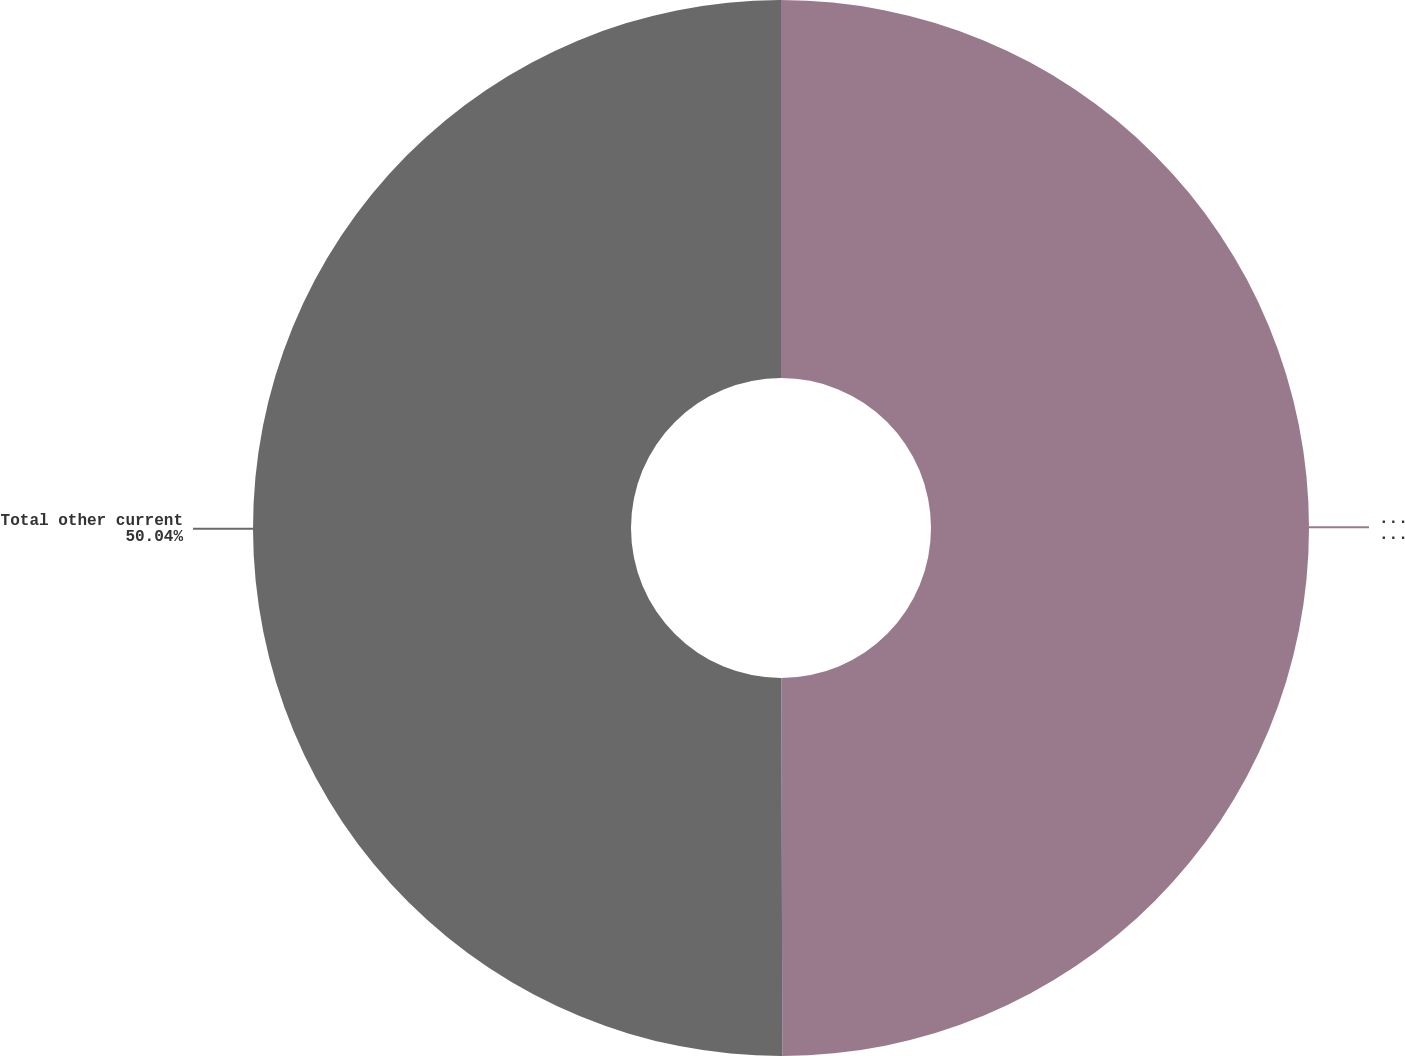<chart> <loc_0><loc_0><loc_500><loc_500><pie_chart><fcel>Other current liabilities<fcel>Total other current<nl><fcel>49.96%<fcel>50.04%<nl></chart> 